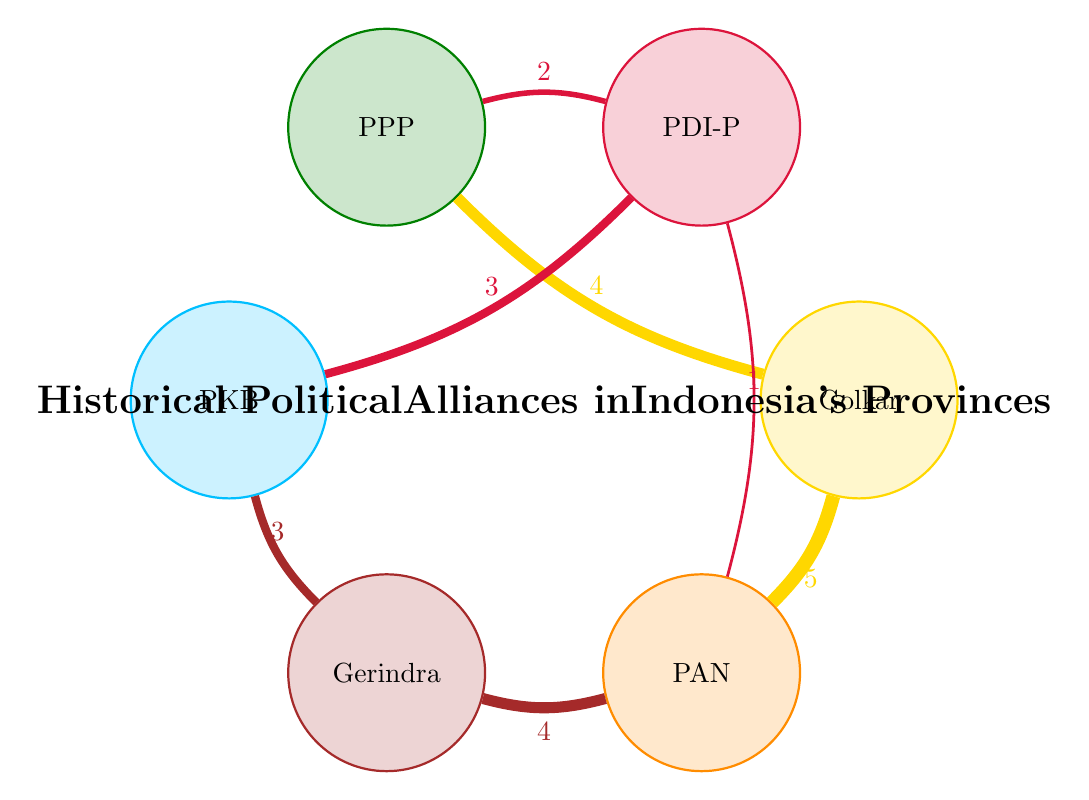What is the highest value link in the diagram? The links represent the connections between nodes and their values indicate the strength of the alliance. By inspecting the connections, the highest value link is between Golkar and PAN, which has a value of 5.
Answer: 5 Which two parties have a direct alliance with PDI-P? To find the parties allied with PDI-P, we look at the connections leading to and from PDI-P. The direct alliances are with PKB (value 3) and PPP (value 2).
Answer: PKB, PPP How many total nodes are present in the diagram? The nodes represent different political parties. Counting them, we have Golkar, PDI-P, PPP, PKB, Gerindra, and PAN, which totals six nodes.
Answer: 6 What is the value of the link between Gerindra and PAN? The link between Gerindra and PAN can be found by checking the connections starting from Gerindra. It shows a value of 4, indicating the strength of their alliance.
Answer: 4 Which party has the most connections in the diagram? By examining each party's connections, it is seen that Golkar has connections to both PPP and PAN, with values of 4 and 5 respectively. Thus, Golkar has the most number of connections (two total).
Answer: Golkar How many connections does PDI-P have in total? Counting the links associated with PDI-P, we observe it connects to PKB (3), PPP (2), and PAN (1), totaling six connections.
Answer: 6 Which party is connected the least in the diagram? Analyzing each party's connections reveals that PDI-P has links with three parties, Golkar with two, and PAN also has two. However, PAN connects only to Gerindra and Golkar, indicating it's the least connected.
Answer: PAN What is the value of the link between Golkar and PPP? We refer to the connection originating from Golkar to PPP, which has a recorded value of 4. This indicates the strength of their alliance.
Answer: 4 